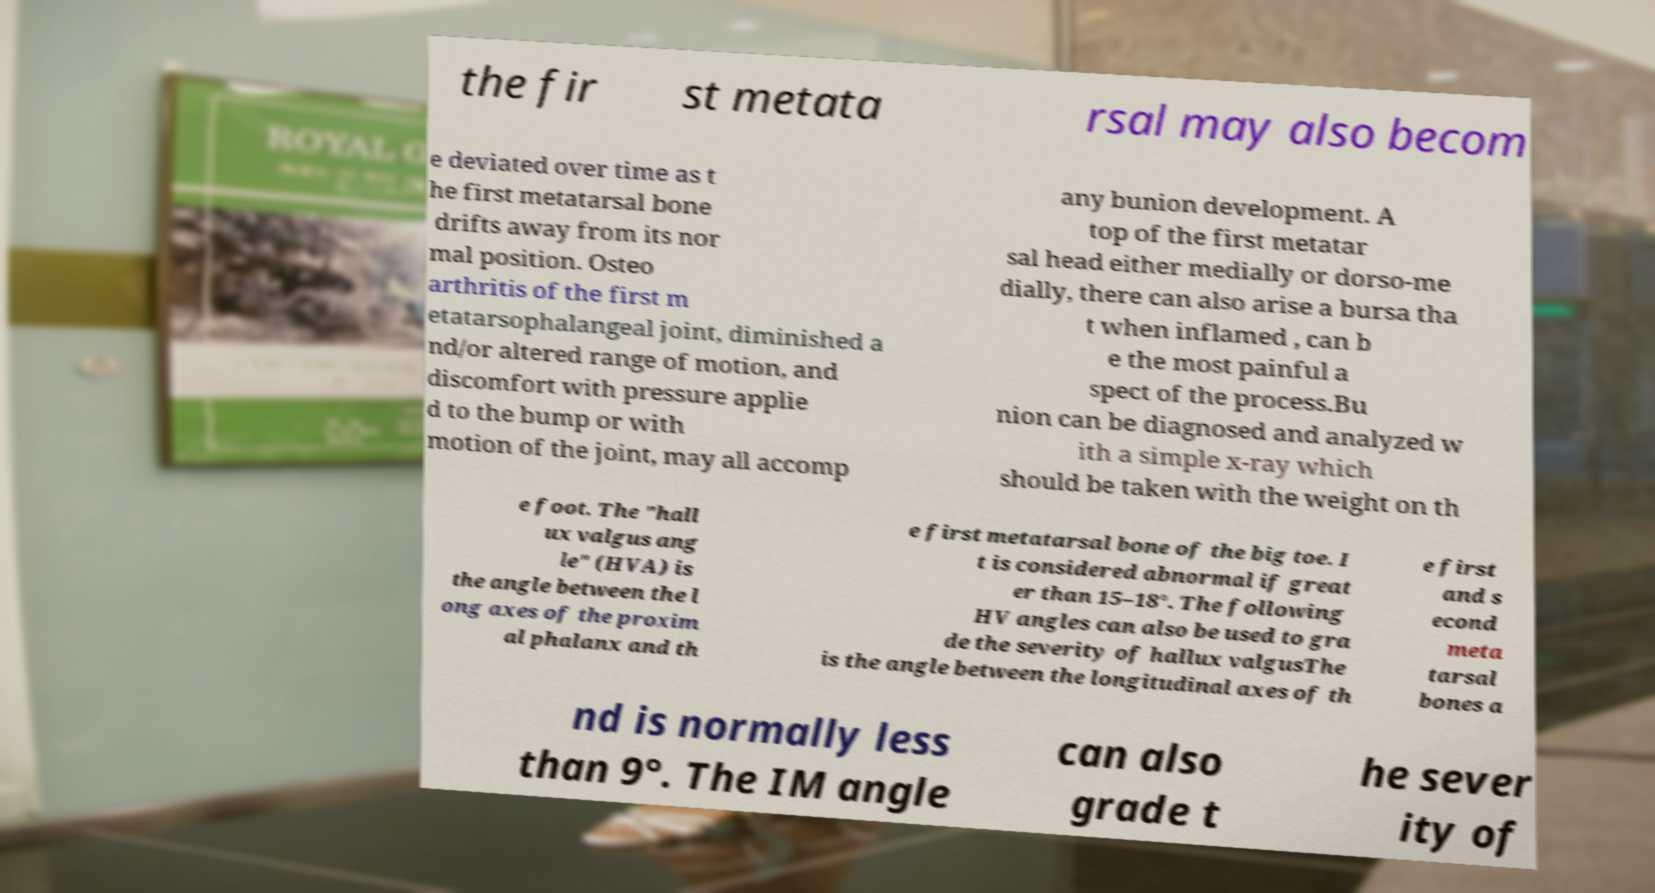What messages or text are displayed in this image? I need them in a readable, typed format. the fir st metata rsal may also becom e deviated over time as t he first metatarsal bone drifts away from its nor mal position. Osteo arthritis of the first m etatarsophalangeal joint, diminished a nd/or altered range of motion, and discomfort with pressure applie d to the bump or with motion of the joint, may all accomp any bunion development. A top of the first metatar sal head either medially or dorso-me dially, there can also arise a bursa tha t when inflamed , can b e the most painful a spect of the process.Bu nion can be diagnosed and analyzed w ith a simple x-ray which should be taken with the weight on th e foot. The "hall ux valgus ang le" (HVA) is the angle between the l ong axes of the proxim al phalanx and th e first metatarsal bone of the big toe. I t is considered abnormal if great er than 15–18°. The following HV angles can also be used to gra de the severity of hallux valgusThe is the angle between the longitudinal axes of th e first and s econd meta tarsal bones a nd is normally less than 9°. The IM angle can also grade t he sever ity of 